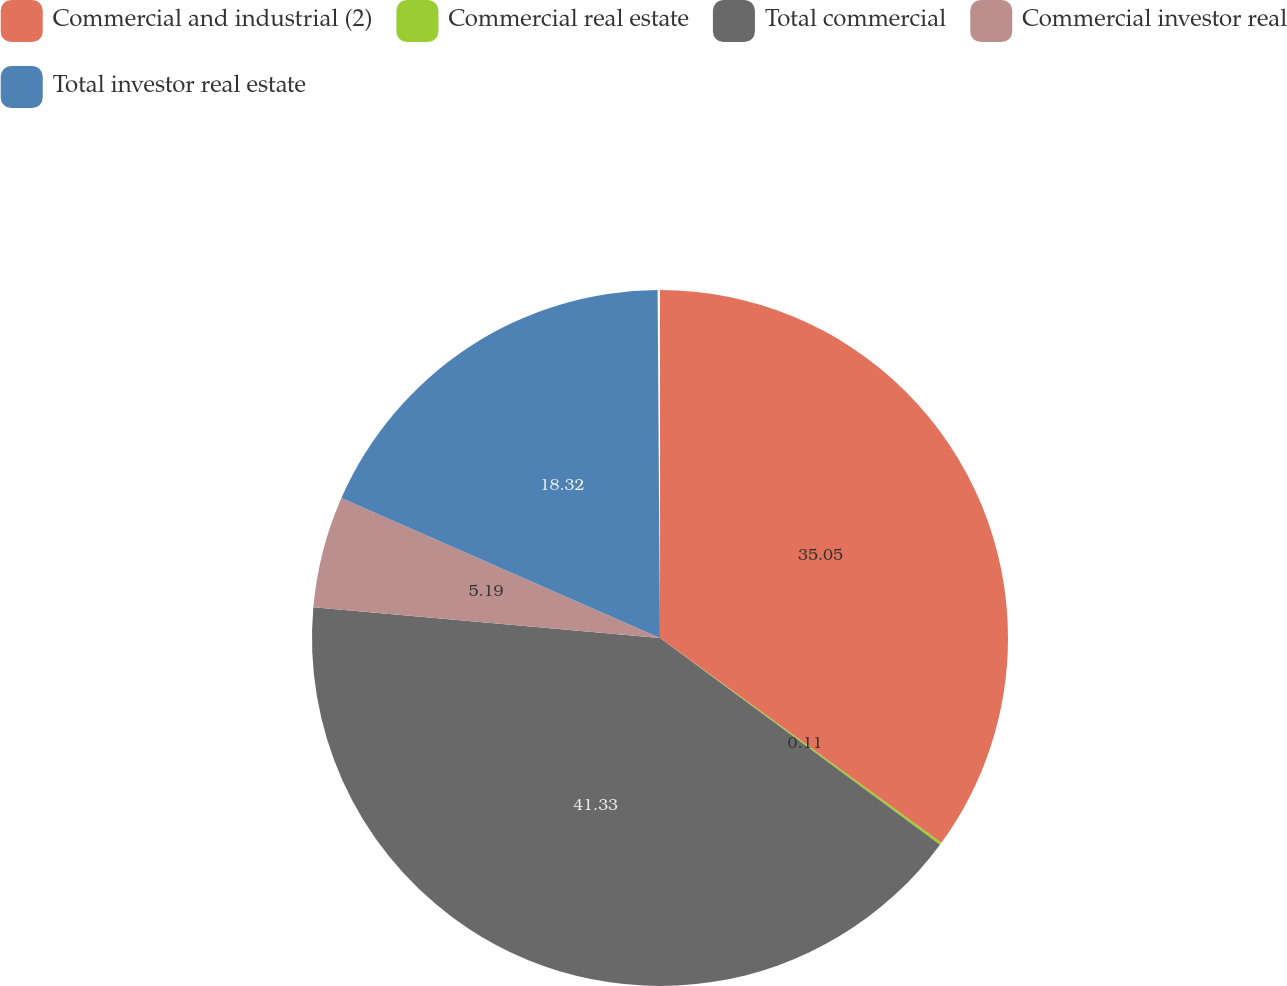<chart> <loc_0><loc_0><loc_500><loc_500><pie_chart><fcel>Commercial and industrial (2)<fcel>Commercial real estate<fcel>Total commercial<fcel>Commercial investor real<fcel>Total investor real estate<nl><fcel>35.05%<fcel>0.11%<fcel>41.33%<fcel>5.19%<fcel>18.32%<nl></chart> 